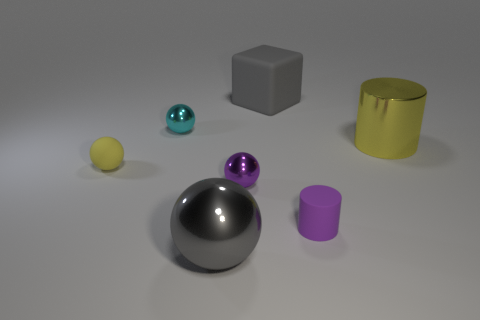Subtract all small rubber balls. How many balls are left? 3 Subtract all yellow spheres. How many spheres are left? 3 Subtract all balls. How many objects are left? 3 Add 2 small matte cylinders. How many objects exist? 9 Subtract all yellow cubes. Subtract all red spheres. How many cubes are left? 1 Subtract all purple cylinders. How many red cubes are left? 0 Subtract all large cyan metal cubes. Subtract all shiny cylinders. How many objects are left? 6 Add 1 matte cylinders. How many matte cylinders are left? 2 Add 5 metal cylinders. How many metal cylinders exist? 6 Subtract 0 brown balls. How many objects are left? 7 